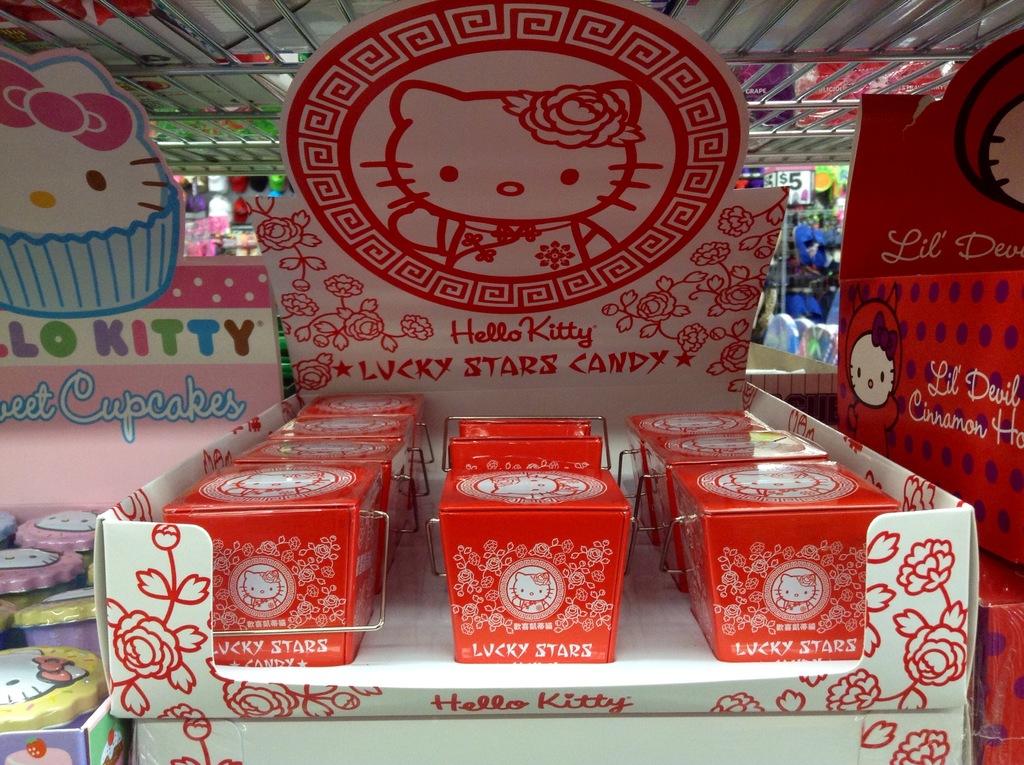What kitty brand is this?
Offer a very short reply. Hello kitty. What kind of candy is this?
Provide a short and direct response. Lucky stars candy. 